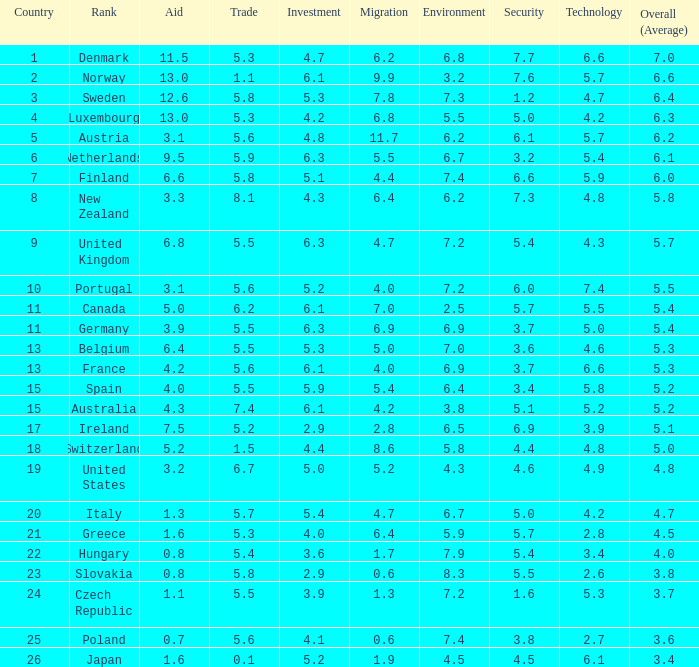What country has a 5.5 mark for security? Slovakia. 